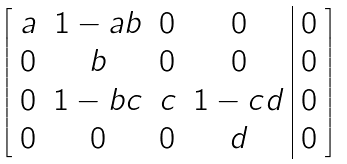Convert formula to latex. <formula><loc_0><loc_0><loc_500><loc_500>\left [ \begin{array} { c c c c | c } a & 1 - a b & 0 & 0 & 0 \\ 0 & b & 0 & 0 & 0 \\ 0 & 1 - b c & c & 1 - c d & 0 \\ 0 & 0 & 0 & d & 0 \end{array} \right ]</formula> 